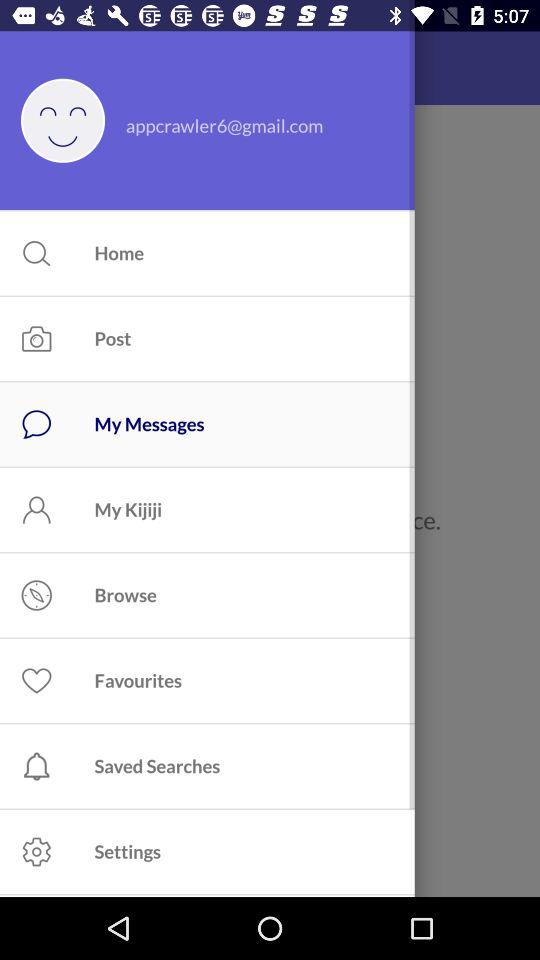What is the email address? The email address is appcrawler6@gmail.com. 